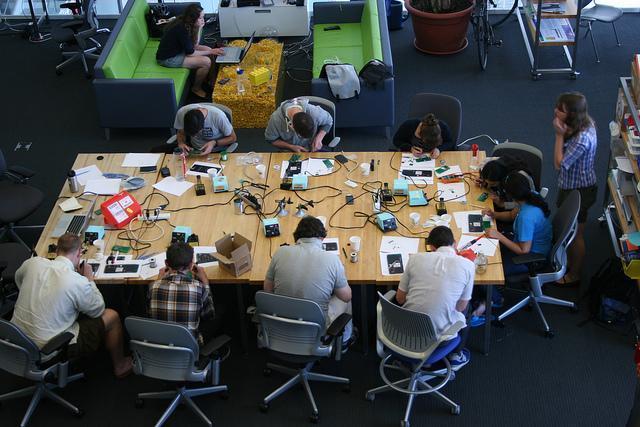How many plants are there?
Give a very brief answer. 0. How many chairs are in the picture?
Give a very brief answer. 7. How many couches are visible?
Give a very brief answer. 2. How many people are there?
Give a very brief answer. 9. 